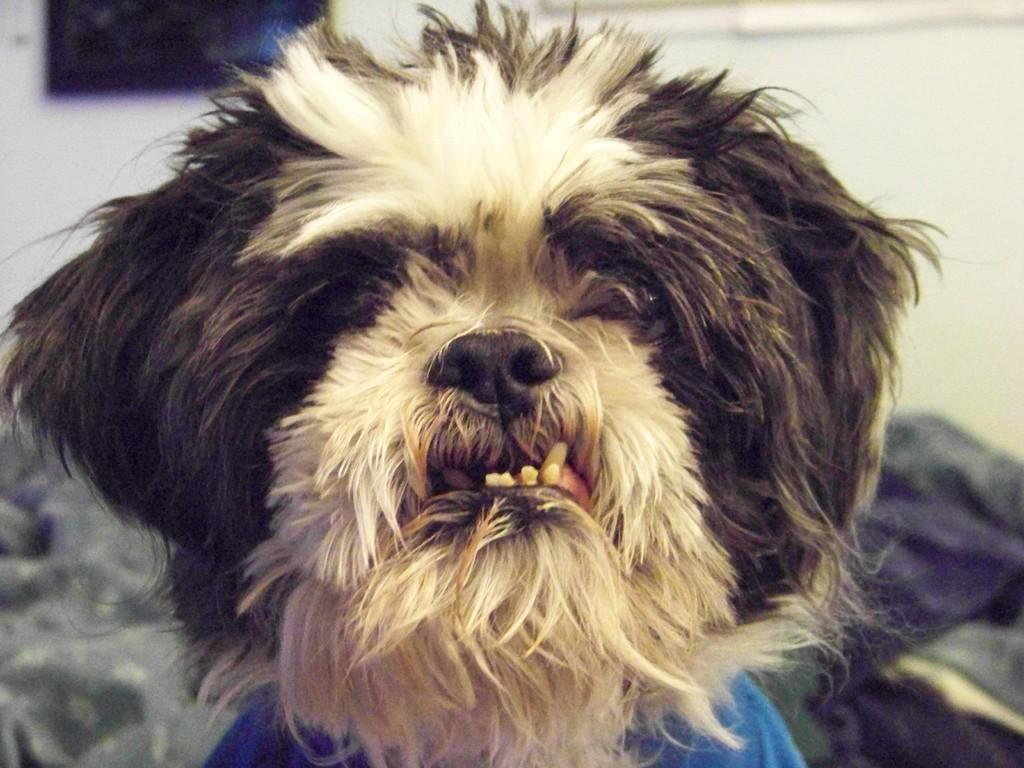Could you give a brief overview of what you see in this image? In this image we can see a dog. In the background, we can see some clothes and the wall. 